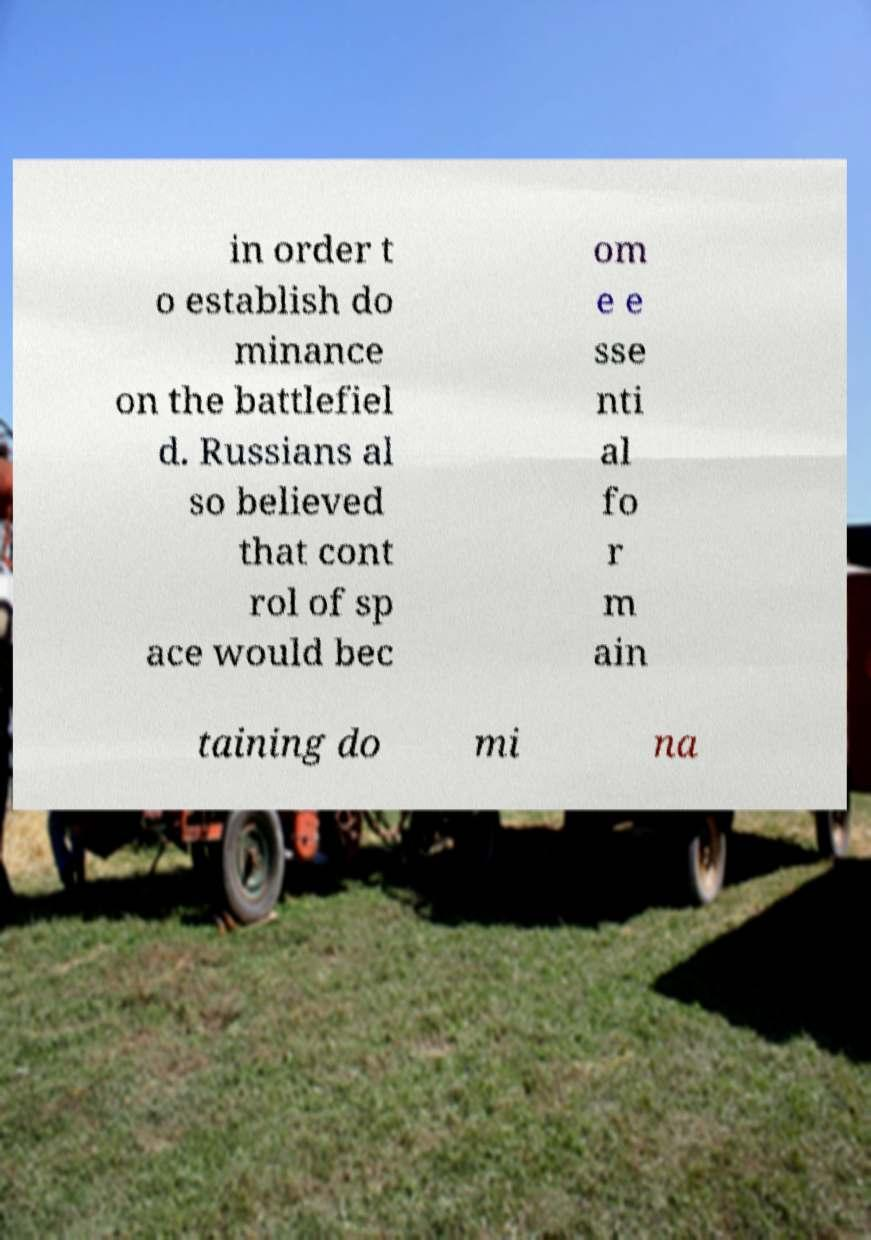There's text embedded in this image that I need extracted. Can you transcribe it verbatim? in order t o establish do minance on the battlefiel d. Russians al so believed that cont rol of sp ace would bec om e e sse nti al fo r m ain taining do mi na 